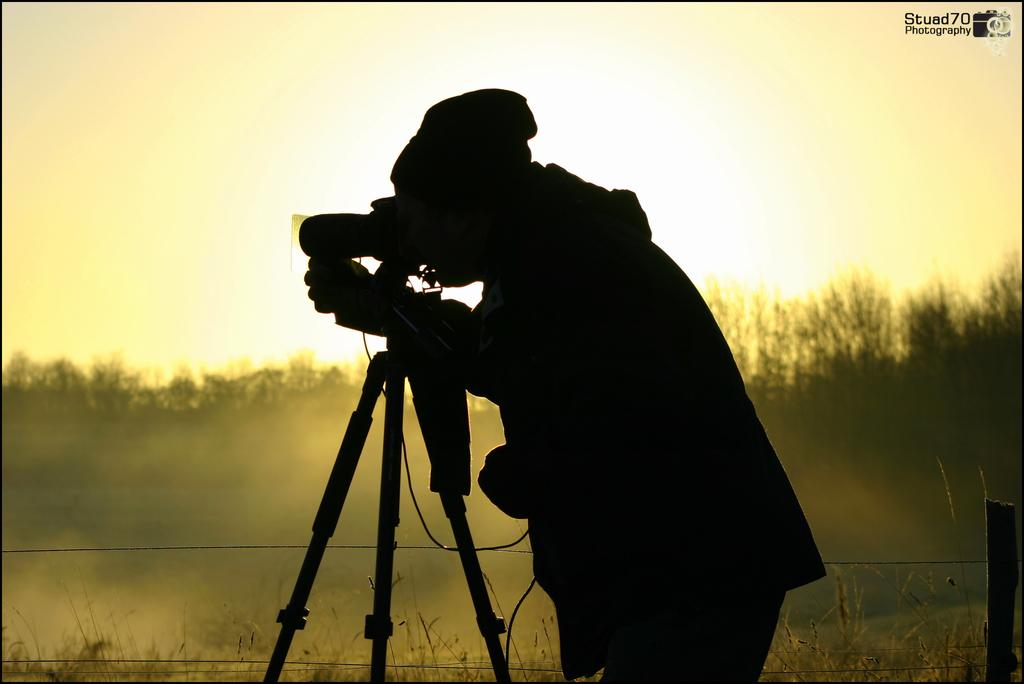What is the main subject of the image? There is a person standing in the image. What object is the person holding in the image? There is a camera in the image. What is the camera resting on in the image? There is a tripod in the image. What can be seen in the background of the image? There is a fence and trees at the back of the image. What type of cakes are being served at the summer volcano party in the image? There is no mention of cakes, summer, or a volcano party in the image. The image only features a person with a camera on a tripod, a fence, and trees in the background. 